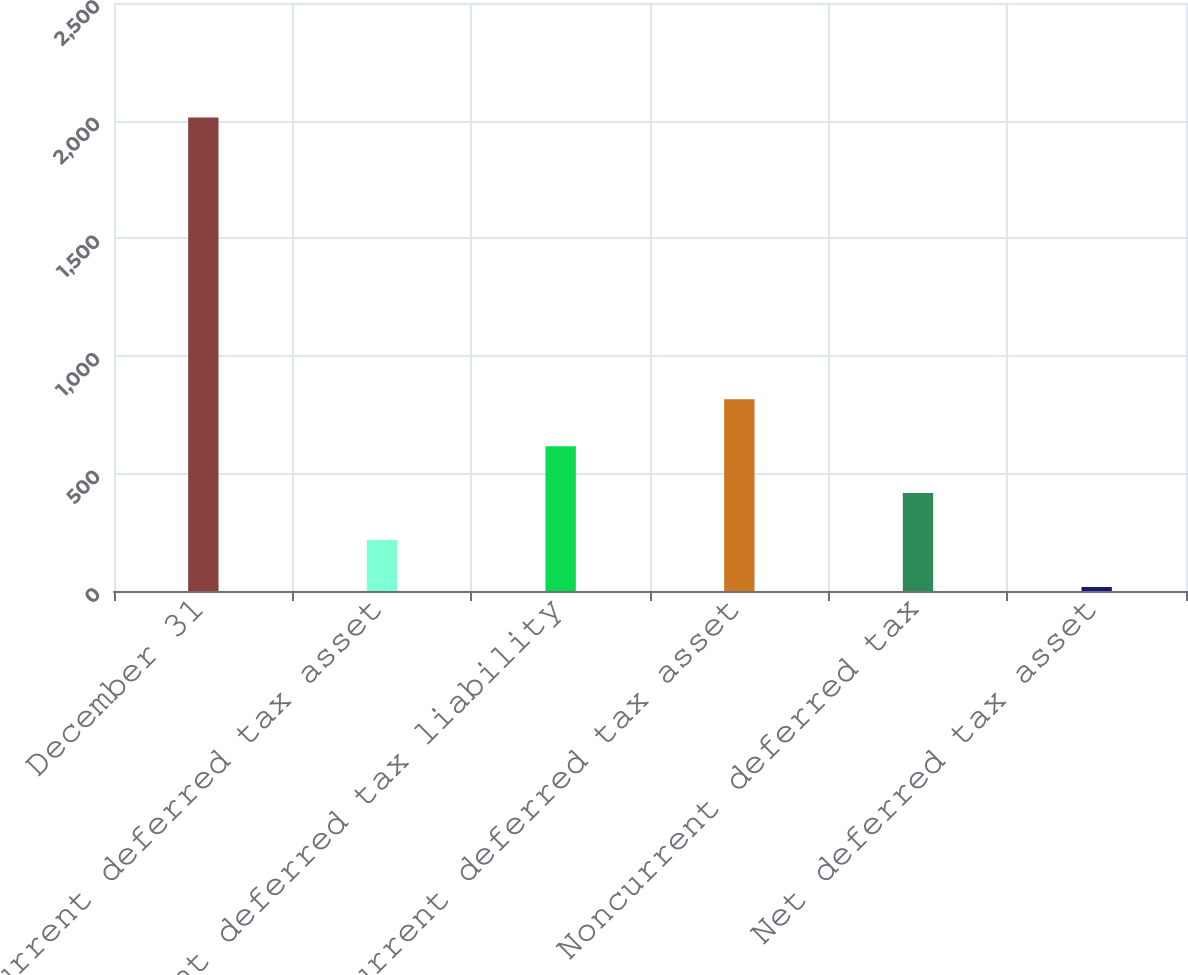Convert chart to OTSL. <chart><loc_0><loc_0><loc_500><loc_500><bar_chart><fcel>December 31<fcel>Current deferred tax asset<fcel>Current deferred tax liability<fcel>Noncurrent deferred tax asset<fcel>Noncurrent deferred tax<fcel>Net deferred tax asset<nl><fcel>2013<fcel>216.6<fcel>615.8<fcel>815.4<fcel>416.2<fcel>17<nl></chart> 